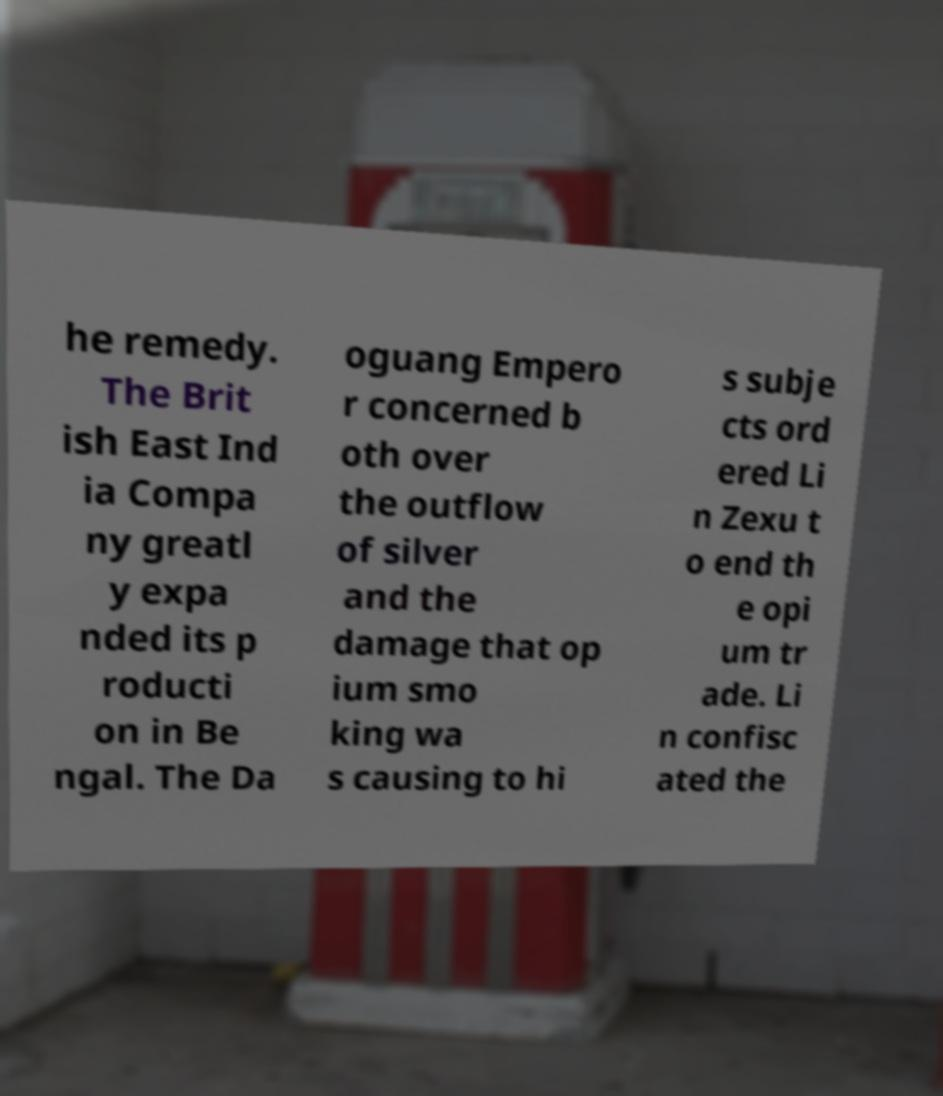Please read and relay the text visible in this image. What does it say? he remedy. The Brit ish East Ind ia Compa ny greatl y expa nded its p roducti on in Be ngal. The Da oguang Empero r concerned b oth over the outflow of silver and the damage that op ium smo king wa s causing to hi s subje cts ord ered Li n Zexu t o end th e opi um tr ade. Li n confisc ated the 